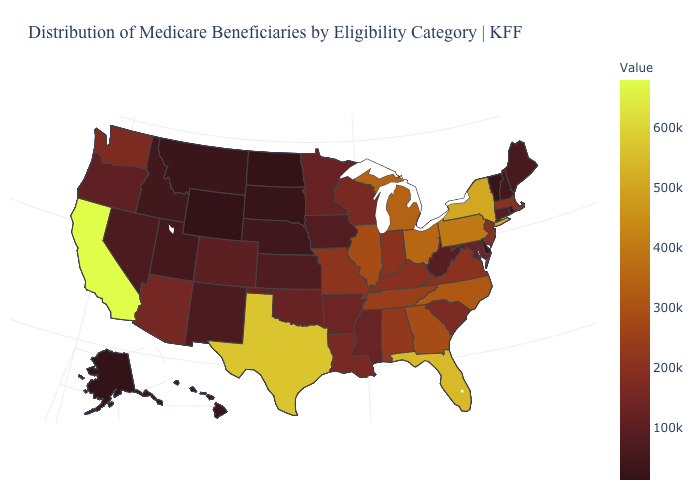Among the states that border New Hampshire , which have the lowest value?
Concise answer only. Vermont. Does New Jersey have the highest value in the USA?
Answer briefly. No. Does Georgia have a higher value than Pennsylvania?
Keep it brief. No. Among the states that border Georgia , does South Carolina have the lowest value?
Short answer required. Yes. Does Nebraska have the lowest value in the USA?
Keep it brief. No. 